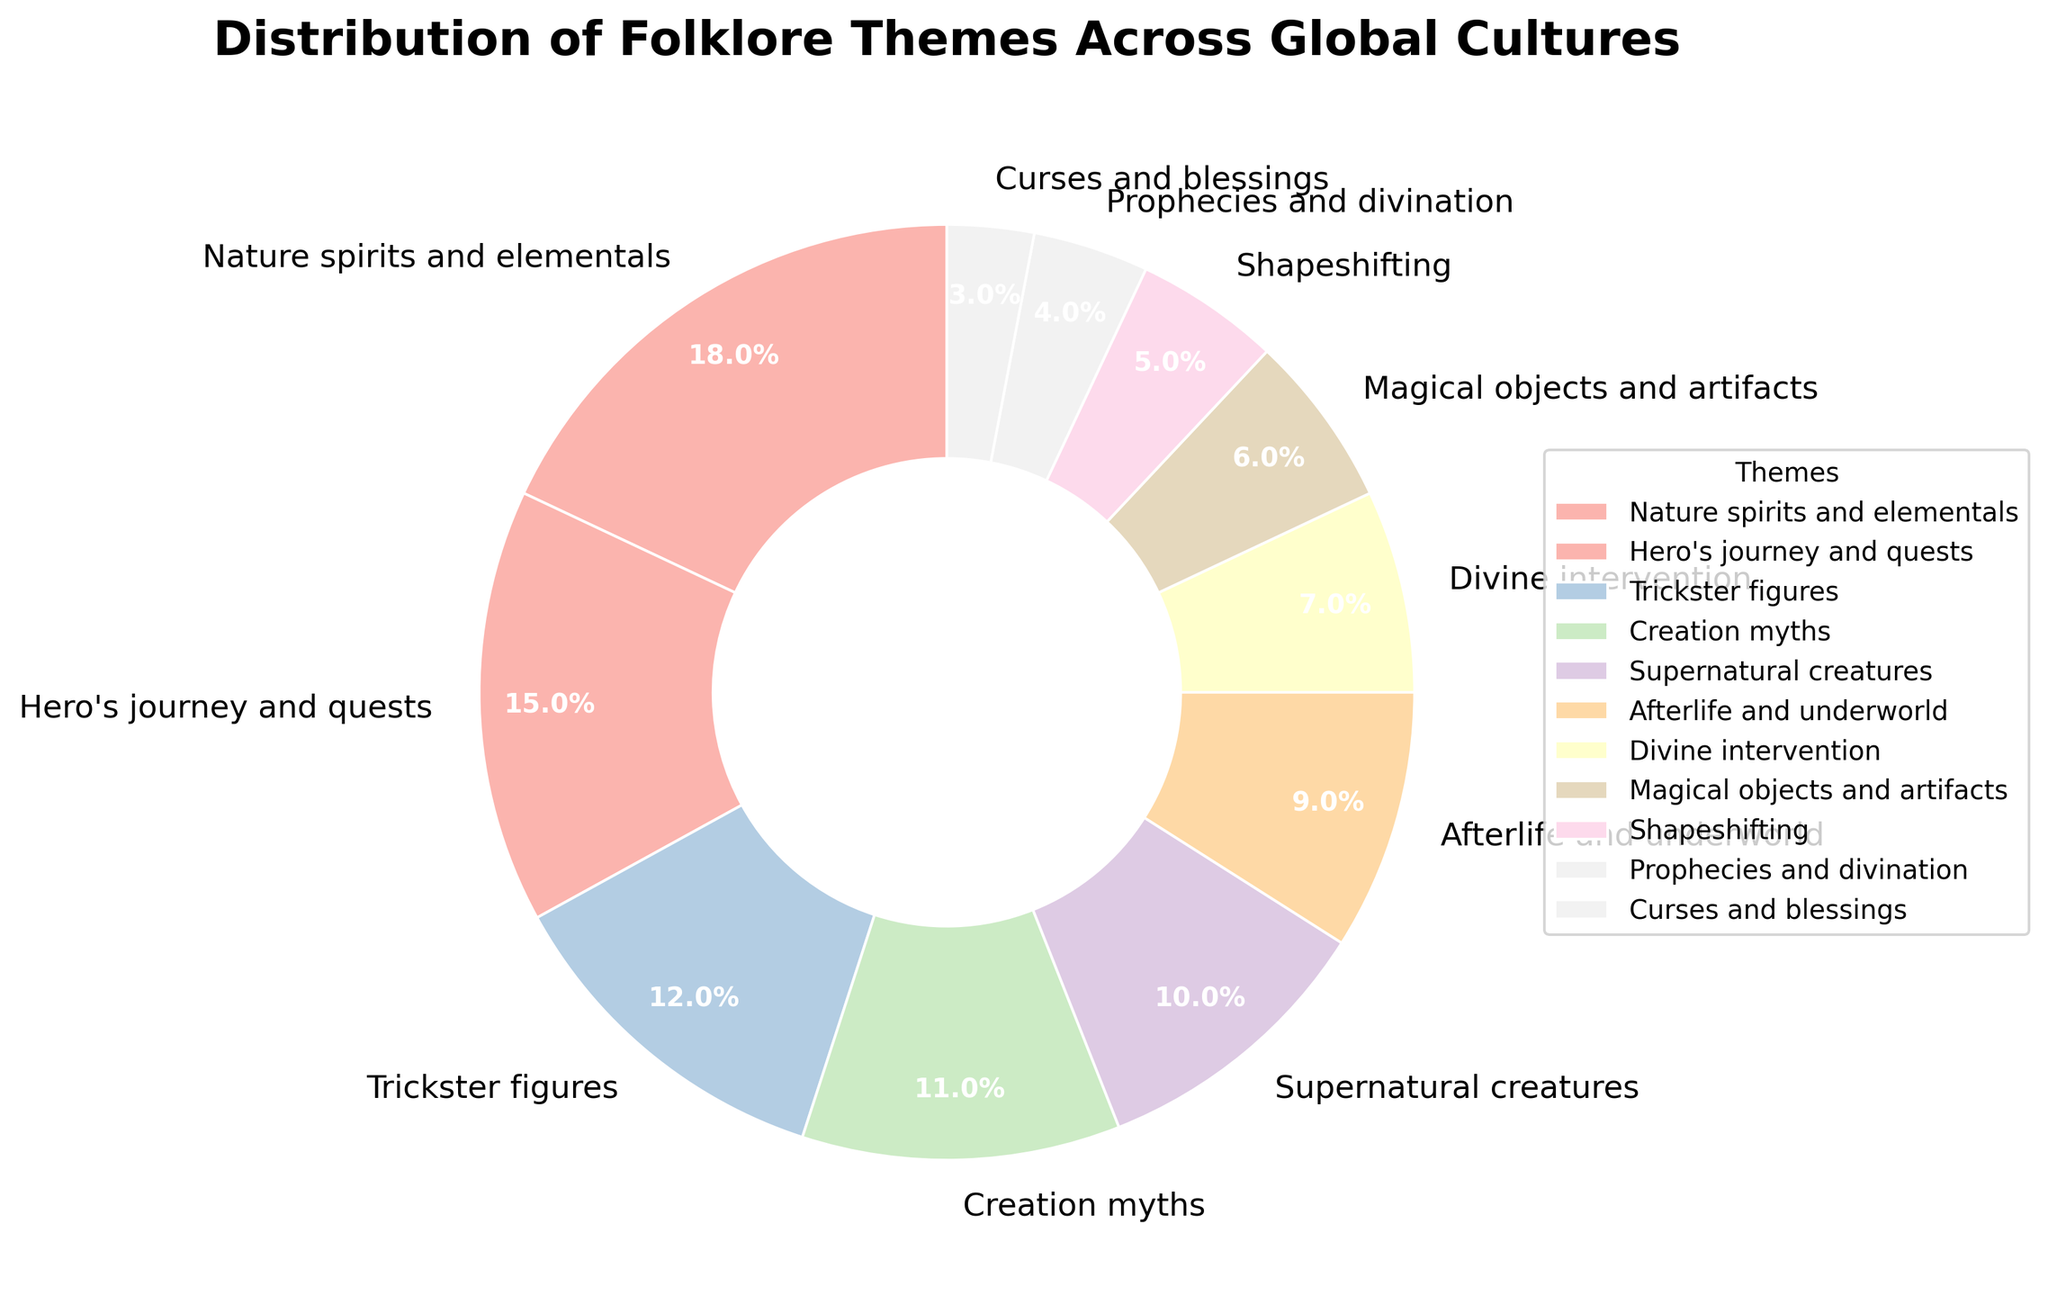Which folklore theme is the most prominent in the figure? The most prominent theme is the one with the largest percentage. Looking at the figure, "Nature spirits and elementals" has the largest portion.
Answer: Nature spirits and elementals What is the combined percentage of "Afterlife and underworld" and "Creation myths" themes? Add the percentages of "Afterlife and underworld" (9%) and "Creation myths" (11%). So, 9% + 11% = 20%.
Answer: 20% Which themes have a combined total of less than 10%? The themes must have individual percentages that sum to less than 10%. "Shapeshifting" is 5%, "Prophecies and divination" is 4%, and "Curses and blessings" is 3%. Any sum including "Shapeshifting" and either of the others exceeds 10%. So, "Prophecies and divination" (4%) and "Curses and blessings" (3%) have a combined total of 7%.
Answer: Prophecies and divination, Curses and blessings How does the size of the "Hero's journey and quests" slice compare to the "Divine intervention" slice? Compare their percentages directly: "Hero's journey and quests" is 15%, while "Divine intervention" is 7%. "Hero's journey and quests" is more than twice the size of "Divine intervention".
Answer: Hero's journey and quests is larger Which two themes combined make up almost one-fourth of the chart? One-fourth is 25%. The combined percentages of these two themes should be close to 25%. Adding 18% ("Nature spirits and elementals") and 7% ("Divine intervention") equals 25%.
Answer: Nature spirits and elementals, Divine intervention What's the difference in percentage between the largest and the smallest theme? Subtract the smallest percentage from the largest percentage. The largest is "Nature spirits and elementals" at 18%, and the smallest is "Curses and blessings" at 3%. So, 18% - 3% = 15%.
Answer: 15% Which themes have a smaller percentage than "Supernatural creatures"? Identify themes with a percentage smaller than 10% (the value for "Supernatural creatures"). They are: "Afterlife and underworld" (9%), "Divine intervention" (7%), "Magical objects and artifacts" (6%), "Shapeshifting" (5%), "Prophecies and divination" (4%), and "Curses and blessings" (3%).
Answer: Afterlife and underworld, Divine intervention, Magical objects and artifacts, Shapeshifting, Prophecies and divination, Curses and blessings How many themes have a percentage of 10% or more? Count the themes with individual percentages of 10% or more: "Nature spirits and elementals" (18%), "Hero's journey and quests" (15%), "Trickster figures" (12%), "Creation myths" (11%), and "Supernatural creatures" (10%). There are 5 such themes.
Answer: 5 What is the average percentage of "Hero's journey and quests", "Trickster figures", and "Magical objects and artifacts"? Sum these percentages: 15% ("Hero's journey and quests"), 12% ("Trickster figures"), 6% ("Magical objects and artifacts") = 33%. Divide by the number of themes: 33% / 3 = 11%.
Answer: 11% 